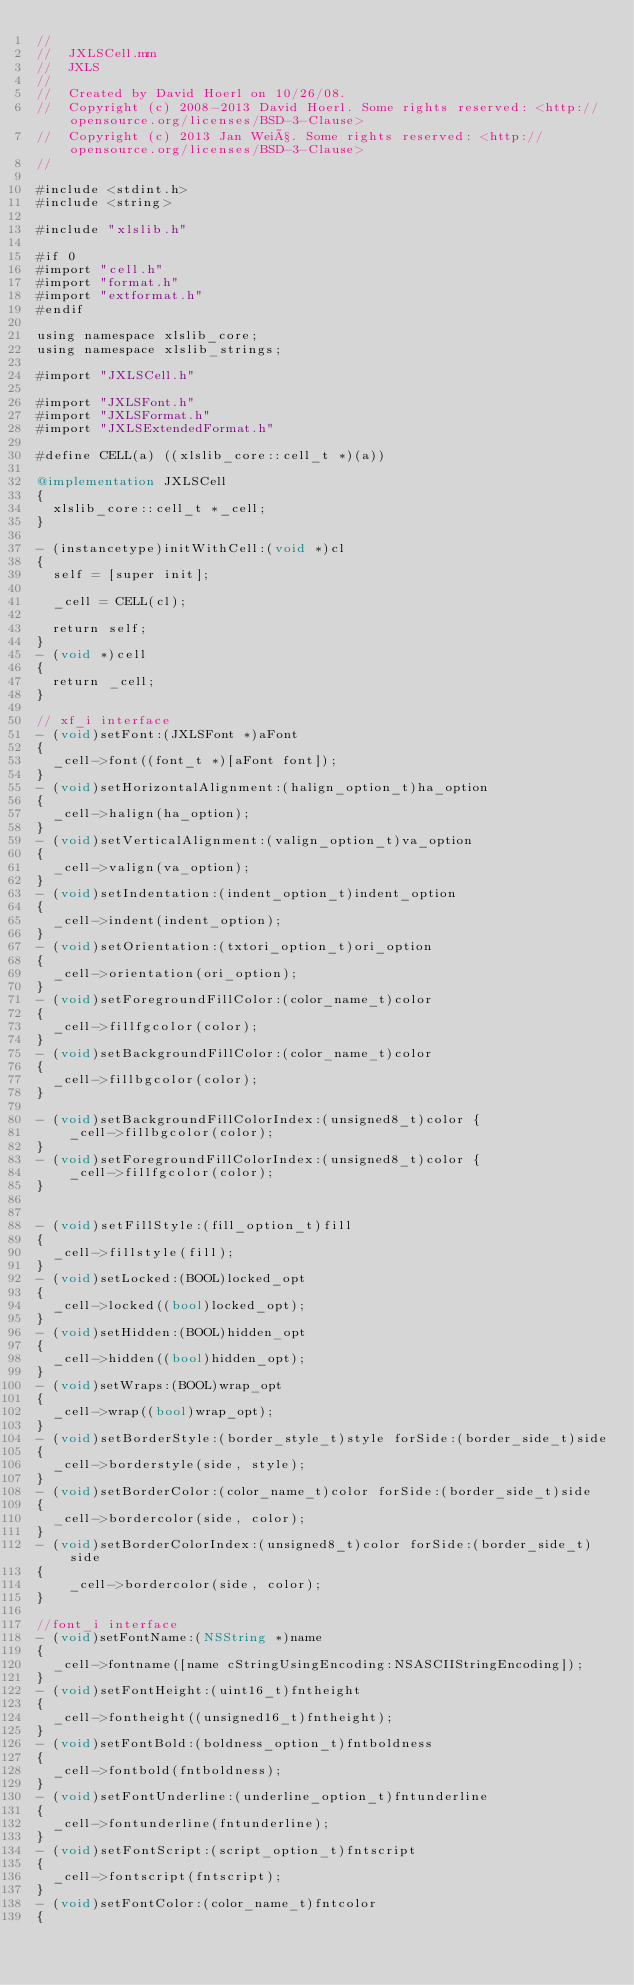Convert code to text. <code><loc_0><loc_0><loc_500><loc_500><_ObjectiveC_>//
//  JXLSCell.mm
//  JXLS
//
//  Created by David Hoerl on 10/26/08.
//  Copyright (c) 2008-2013 David Hoerl. Some rights reserved: <http://opensource.org/licenses/BSD-3-Clause>
//  Copyright (c) 2013 Jan Weiß. Some rights reserved: <http://opensource.org/licenses/BSD-3-Clause>
//

#include <stdint.h>
#include <string>

#include "xlslib.h"

#if 0
#import "cell.h"
#import "format.h"
#import "extformat.h"
#endif

using namespace xlslib_core;
using namespace xlslib_strings;

#import "JXLSCell.h"

#import "JXLSFont.h"
#import "JXLSFormat.h"
#import "JXLSExtendedFormat.h"

#define CELL(a) ((xlslib_core::cell_t *)(a))

@implementation JXLSCell
{
	xlslib_core::cell_t *_cell;
}

- (instancetype)initWithCell:(void *)cl
{
	self = [super init];
	
	_cell = CELL(cl);
	
	return self;
}
- (void *)cell
{
	return _cell;
}

// xf_i interface
- (void)setFont:(JXLSFont *)aFont
{
	_cell->font((font_t *)[aFont font]);
}
- (void)setHorizontalAlignment:(halign_option_t)ha_option
{
	_cell->halign(ha_option);
}
- (void)setVerticalAlignment:(valign_option_t)va_option
{
	_cell->valign(va_option);
}
- (void)setIndentation:(indent_option_t)indent_option
{
	_cell->indent(indent_option);
}
- (void)setOrientation:(txtori_option_t)ori_option
{
	_cell->orientation(ori_option);
}
- (void)setForegroundFillColor:(color_name_t)color
{
	_cell->fillfgcolor(color);
}
- (void)setBackgroundFillColor:(color_name_t)color
{
	_cell->fillbgcolor(color);
}

- (void)setBackgroundFillColorIndex:(unsigned8_t)color {
    _cell->fillbgcolor(color);
}
- (void)setForegroundFillColorIndex:(unsigned8_t)color {
    _cell->fillfgcolor(color);
}


- (void)setFillStyle:(fill_option_t)fill
{
	_cell->fillstyle(fill);
}
- (void)setLocked:(BOOL)locked_opt
{
	_cell->locked((bool)locked_opt);
}
- (void)setHidden:(BOOL)hidden_opt
{
	_cell->hidden((bool)hidden_opt);
}
- (void)setWraps:(BOOL)wrap_opt
{
	_cell->wrap((bool)wrap_opt);
}
- (void)setBorderStyle:(border_style_t)style forSide:(border_side_t)side
{
	_cell->borderstyle(side, style);
}
- (void)setBorderColor:(color_name_t)color forSide:(border_side_t)side
{
	_cell->bordercolor(side, color);
}
- (void)setBorderColorIndex:(unsigned8_t)color forSide:(border_side_t)side
{
    _cell->bordercolor(side, color);
}

//font_i interface
- (void)setFontName:(NSString *)name
{
	_cell->fontname([name cStringUsingEncoding:NSASCIIStringEncoding]);
}
- (void)setFontHeight:(uint16_t)fntheight
{
	_cell->fontheight((unsigned16_t)fntheight);
}
- (void)setFontBold:(boldness_option_t)fntboldness
{
	_cell->fontbold(fntboldness);
}
- (void)setFontUnderline:(underline_option_t)fntunderline
{
	_cell->fontunderline(fntunderline);
}
- (void)setFontScript:(script_option_t)fntscript
{
	_cell->fontscript(fntscript);
}
- (void)setFontColor:(color_name_t)fntcolor
{</code> 